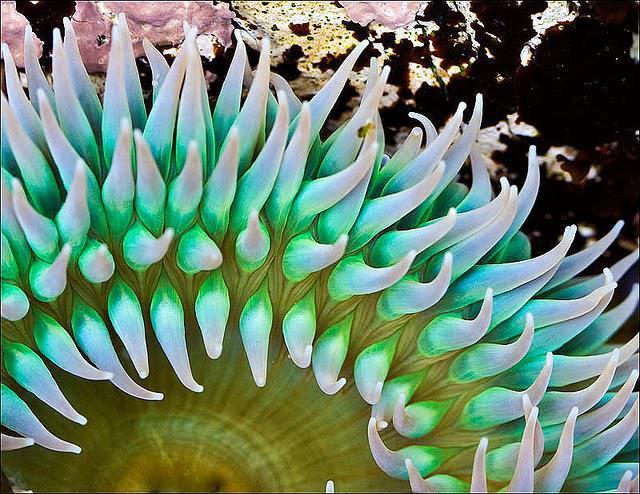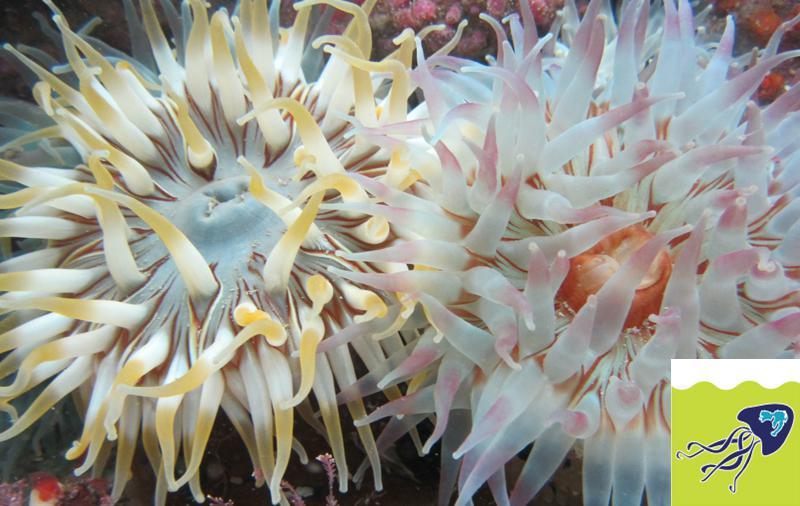The first image is the image on the left, the second image is the image on the right. For the images shown, is this caption "One image includes at least ten dark fish with white dots swimming above one large, pale, solid-colored anemone." true? Answer yes or no. No. The first image is the image on the left, the second image is the image on the right. For the images displayed, is the sentence "There are at least 10 small black and white fish swimming through corral." factually correct? Answer yes or no. No. 